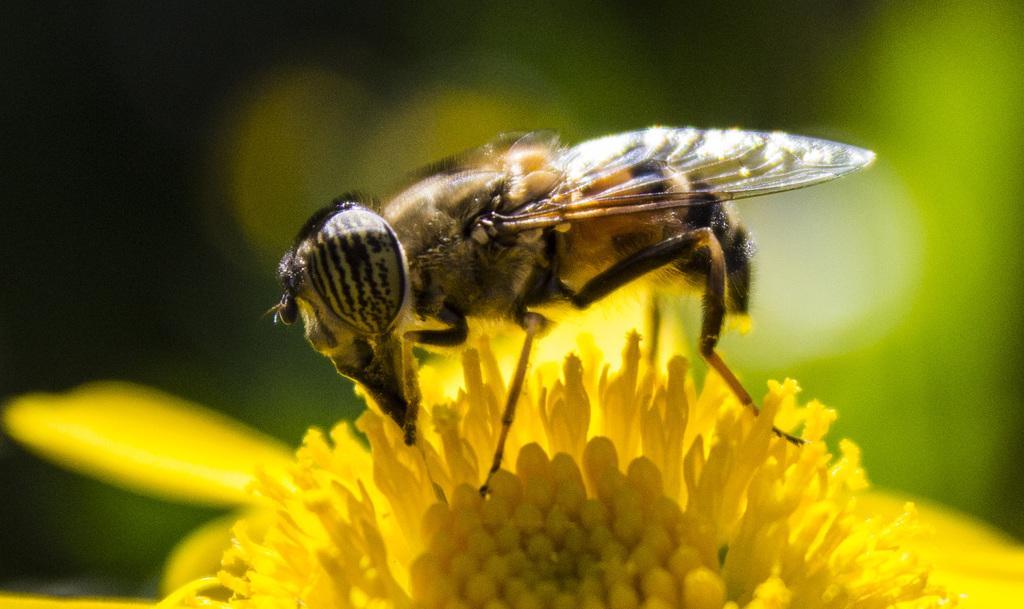In one or two sentences, can you explain what this image depicts? In this image in the front there is an insect on the flower and the background is blurry. 